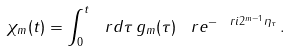<formula> <loc_0><loc_0><loc_500><loc_500>\chi _ { m } ( t ) = \int _ { 0 } ^ { t } \ r d \tau \, g _ { m } ( \tau ) \, \ r e ^ { - \ r i 2 ^ { m - 1 } \eta _ { \tau } } \, .</formula> 